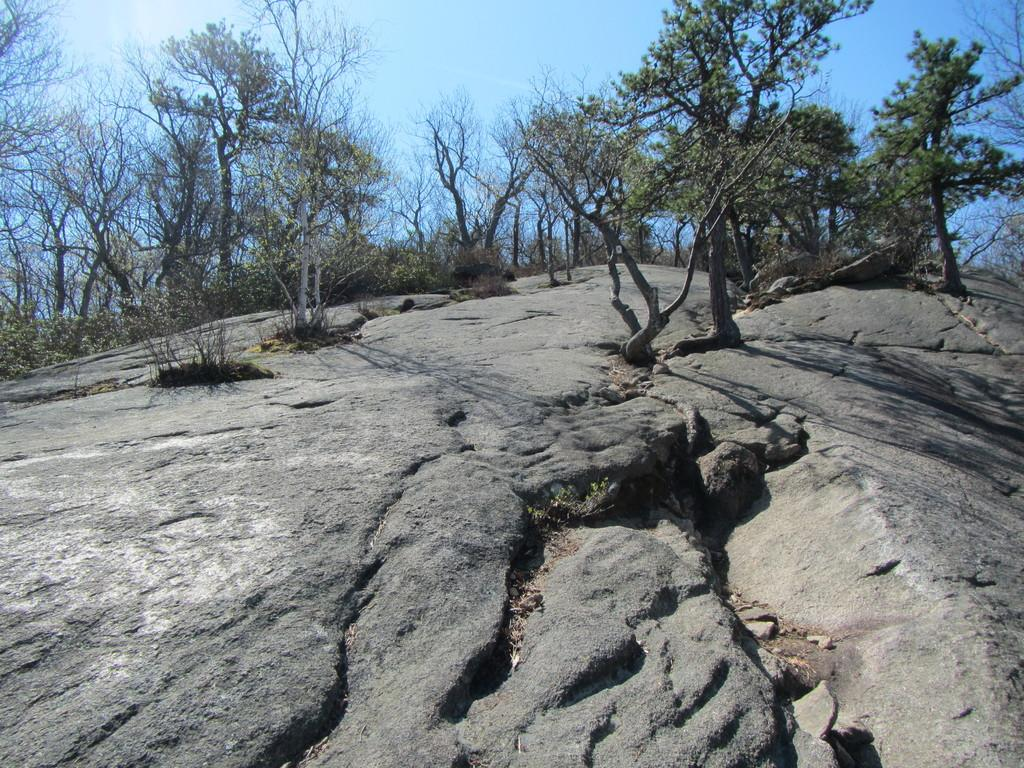What type of vegetation can be seen on the mountain in the image? There are trees on a mountain in the image. What color is the sky visible at the top of the image? The sky is blue at the top of the image. How many lizards can be seen climbing the trees on the mountain in the image? There are no lizards visible in the image; it only features trees on a mountain. What type of memory is being used by the trees to store information about the weather? Trees do not have a memory system like humans or animals; they respond to environmental changes through their physiological processes. 